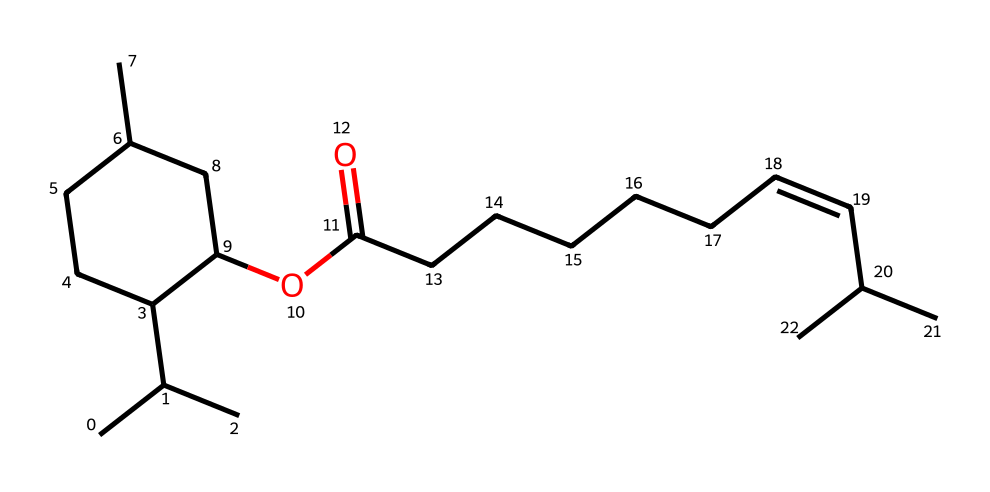How many carbon atoms are present in the chemical structure? To determine the number of carbon atoms, we need to count the "C" symbols in the SMILES representation. Each capital "C" represents a carbon atom, and from the provided SMILES, there are 21 carbon atoms in total.
Answer: 21 What functional group is represented in this chemical structure? Examining the SMILES, we notice the presence of "OC(=O)" which signifies the presence of an ester functional group. This part shows a carbonyl (C=O) connected to an oxygen (O).
Answer: ester How many double bonds are present in this structure? We identify double bonds by looking for "=" symbols in the SMILES representation. In the structure provided, there is one double bond found in the "/C=C/" sequence.
Answer: 1 What type of lipid does this compound likely represent? Considering the structure of this chemical, especially the long carbon chain and functional groups, it most closely resembles a triglyceride due to its fatty acid structure.
Answer: triglyceride What does the "C(C)" notation indicate in terms of structure? The "C(C)" notation indicates branching in the carbon chain, specifically that a carbon atom (the second "C") is connected to another carbon (the first "C") as a side chain. This branching is significant for determining molecular shape and properties.
Answer: branching 